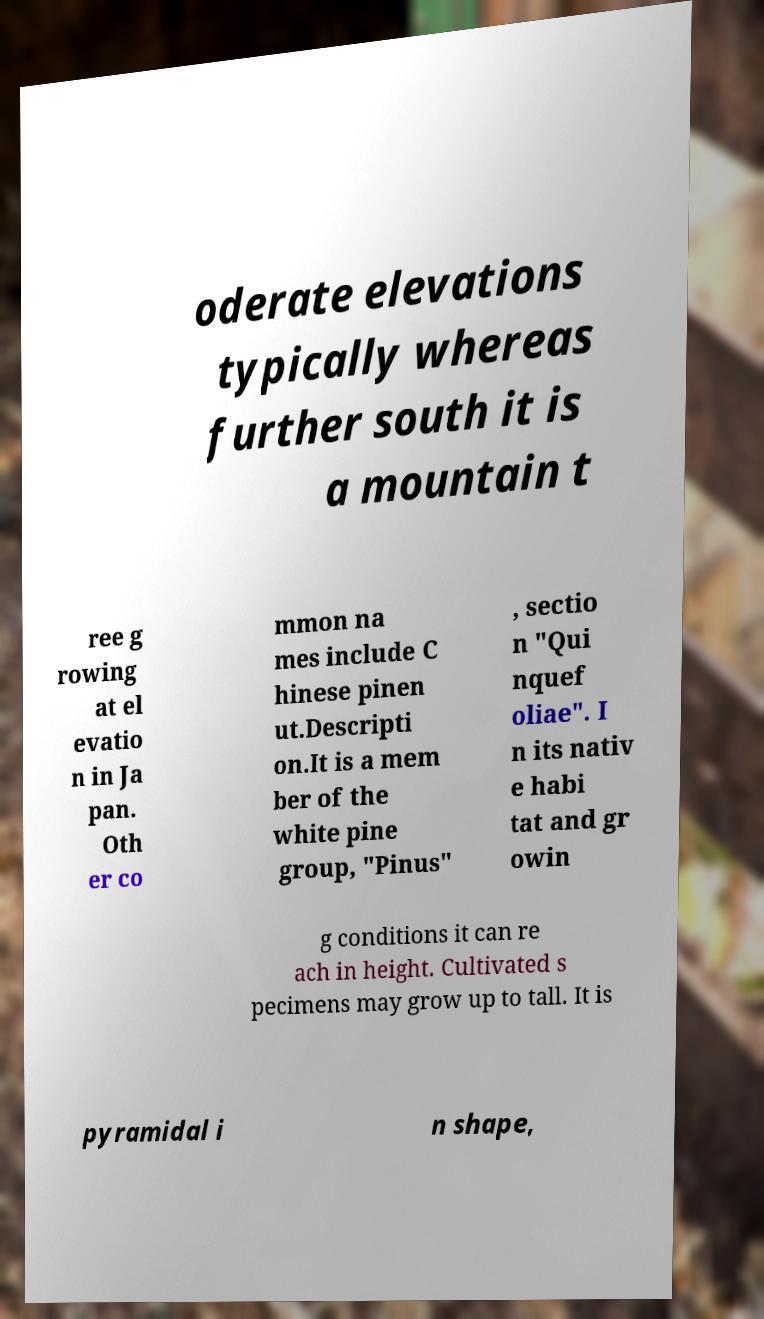There's text embedded in this image that I need extracted. Can you transcribe it verbatim? oderate elevations typically whereas further south it is a mountain t ree g rowing at el evatio n in Ja pan. Oth er co mmon na mes include C hinese pinen ut.Descripti on.It is a mem ber of the white pine group, "Pinus" , sectio n "Qui nquef oliae". I n its nativ e habi tat and gr owin g conditions it can re ach in height. Cultivated s pecimens may grow up to tall. It is pyramidal i n shape, 